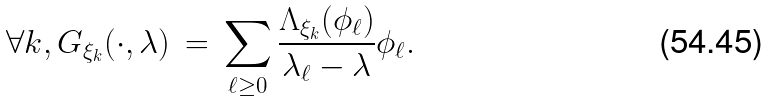Convert formula to latex. <formula><loc_0><loc_0><loc_500><loc_500>\forall k , G _ { \xi _ { k } } ( \cdot , \lambda ) \, = \, \sum _ { \ell \geq 0 } \frac { \Lambda _ { \xi _ { k } } ( \phi _ { \ell } ) } { \lambda _ { \ell } - \lambda } \phi _ { \ell } .</formula> 